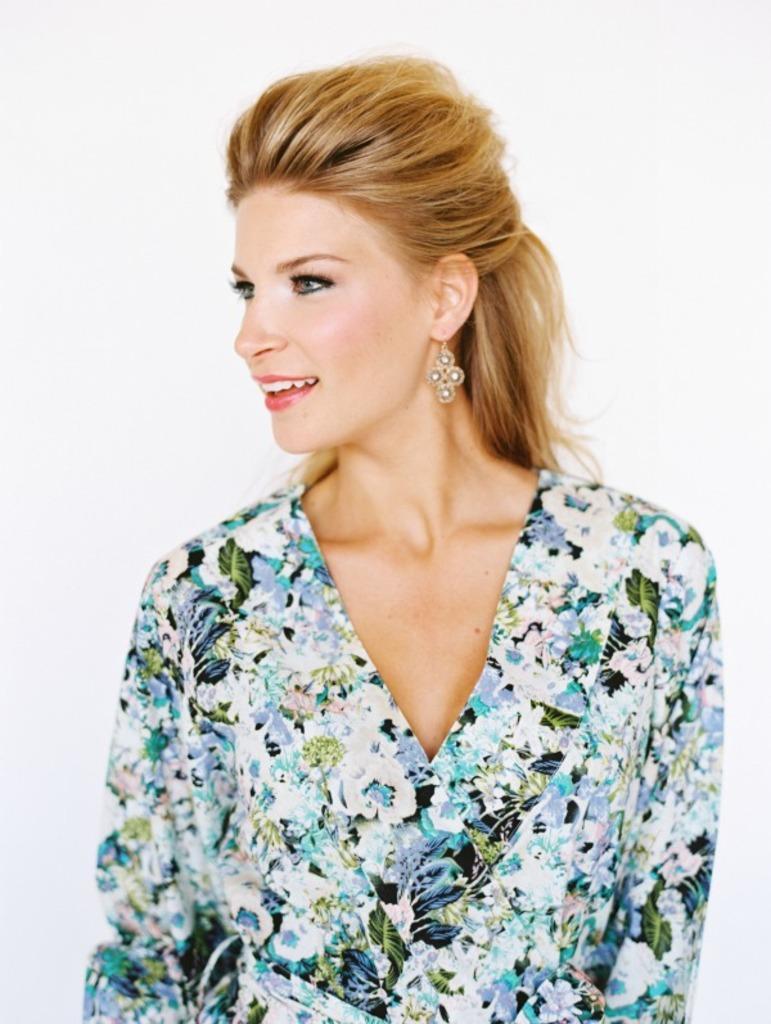Describe this image in one or two sentences. In this image in the center there is one woman who is smiling, and there is white background. 